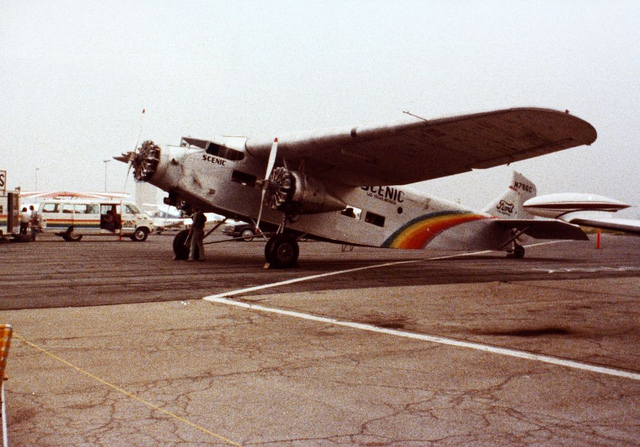What is the number on the front of the plane? The front of the plane features several markings, but the key identifiable number is 'N10609' displayed on the tail, which serves as the aircraft's registration number. 